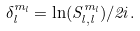<formula> <loc_0><loc_0><loc_500><loc_500>\delta _ { l } ^ { m _ { l } } = \ln ( S _ { l , l } ^ { m _ { l } } ) / 2 i .</formula> 